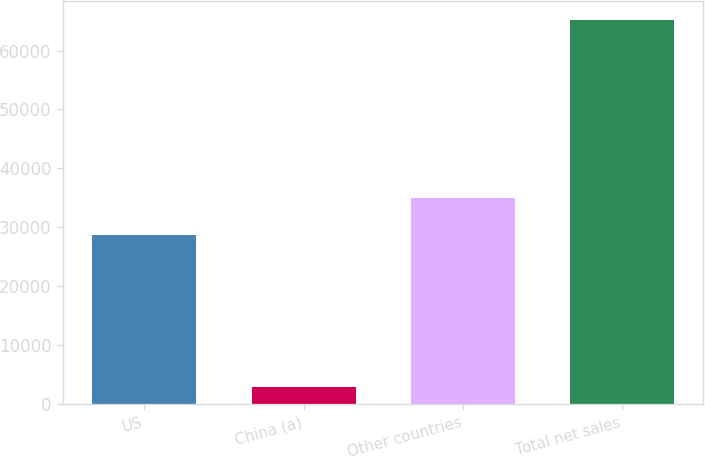<chart> <loc_0><loc_0><loc_500><loc_500><bar_chart><fcel>US<fcel>China (a)<fcel>Other countries<fcel>Total net sales<nl><fcel>28633<fcel>2764<fcel>34879.1<fcel>65225<nl></chart> 